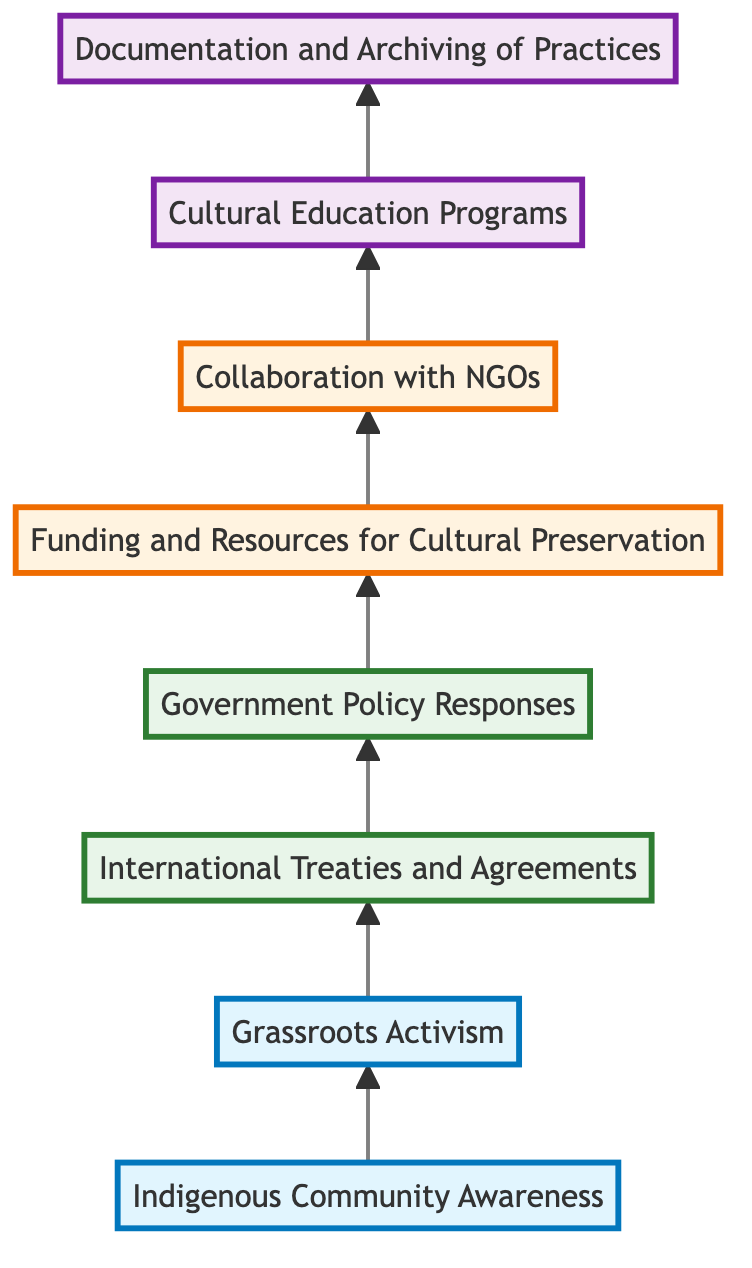What is the starting point of the flow chart? The flow chart begins with "Indigenous Community Awareness," which is the first node before any other connections are made.
Answer: Indigenous Community Awareness How many nodes are there in the diagram? By counting the different elements presented in the diagram, there are eight distinct nodes that are visible.
Answer: 8 Which node comes directly after "Grassroots Activism"? The diagram shows that "Grassroots Activism" has a direct connection flowing to "International Treaties and Agreements"; this is the next immediate node.
Answer: International Treaties and Agreements What type of collaboration is indicated in the chart? The chart connects "Collaboration with NGOs," which suggests partnerships between indigenous communities and non-governmental organizations aimed at preserving cultural practices.
Answer: Collaboration with NGOs What is the last step in the flow depicted by the chart? The final node in the flowchart is "Documentation and Archiving of Practices," indicating this is the culmination of all preceding efforts.
Answer: Documentation and Archiving of Practices How are "Government Policy Responses" influenced according to the chart? The chart indicates that "International Treaties and Agreements" exert influence, resulting in "Government Policy Responses" that affect indigenous rights and cultural preservation.
Answer: International Treaties and Agreements Which type of education program is mentioned, and what is its purpose? The flowchart specifies "Cultural Education Programs," aimed at educating the wider society about indigenous beliefs and to foster respect and understanding.
Answer: Cultural Education Programs What resource is linked to "Funding and Resources for Cultural Preservation"? "Collaboration with NGOs" is the next step that connects back to "Funding and Resources for Cultural Preservation," implying NGOs provide the necessary support for these initiatives.
Answer: Collaboration with NGOs 